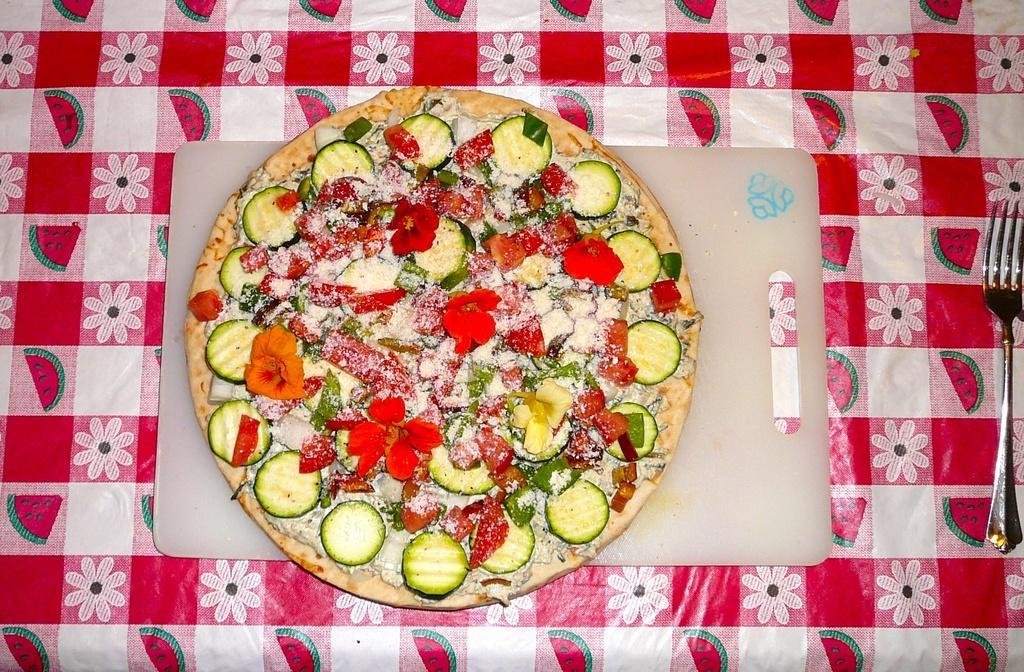How would you summarize this image in a sentence or two? In this image we can see a food item on a cutting table. On the right side there is a fork. Also there is a tablecloth. 